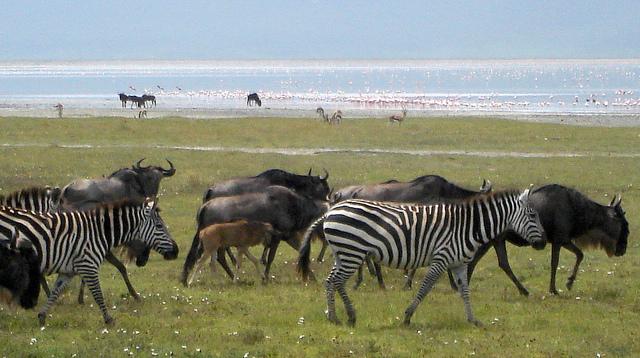How many zebras are in the photo?
Write a very short answer. 3. How many stripes are there?
Give a very brief answer. 50. Is everything moving in the same direction?
Give a very brief answer. No. 